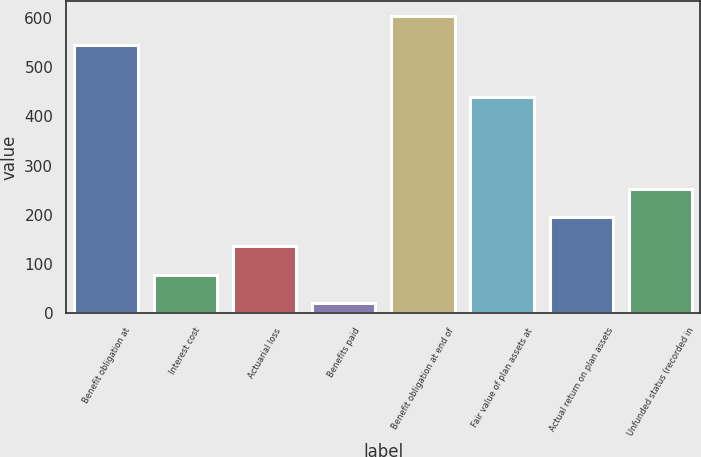<chart> <loc_0><loc_0><loc_500><loc_500><bar_chart><fcel>Benefit obligation at<fcel>Interest cost<fcel>Actuarial loss<fcel>Benefits paid<fcel>Benefit obligation at end of<fcel>Fair value of plan assets at<fcel>Actual return on plan assets<fcel>Unfunded status (recorded in<nl><fcel>546<fcel>78.3<fcel>136.6<fcel>20<fcel>604.3<fcel>439.3<fcel>194.9<fcel>253.2<nl></chart> 